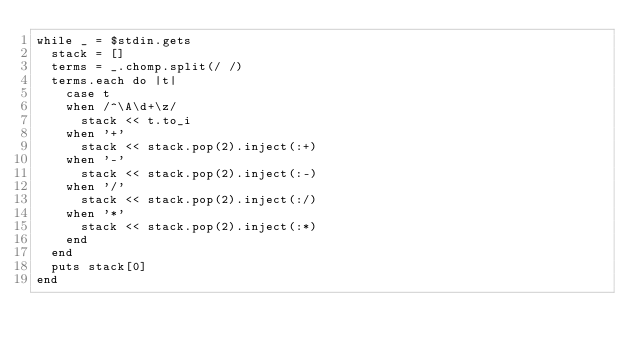<code> <loc_0><loc_0><loc_500><loc_500><_Ruby_>while _ = $stdin.gets
  stack = []
  terms = _.chomp.split(/ /)
  terms.each do |t|
    case t
    when /^\A\d+\z/
      stack << t.to_i
    when '+'
      stack << stack.pop(2).inject(:+)
    when '-'
      stack << stack.pop(2).inject(:-)
    when '/'
      stack << stack.pop(2).inject(:/)
    when '*'
      stack << stack.pop(2).inject(:*)
    end
  end
  puts stack[0]
end</code> 